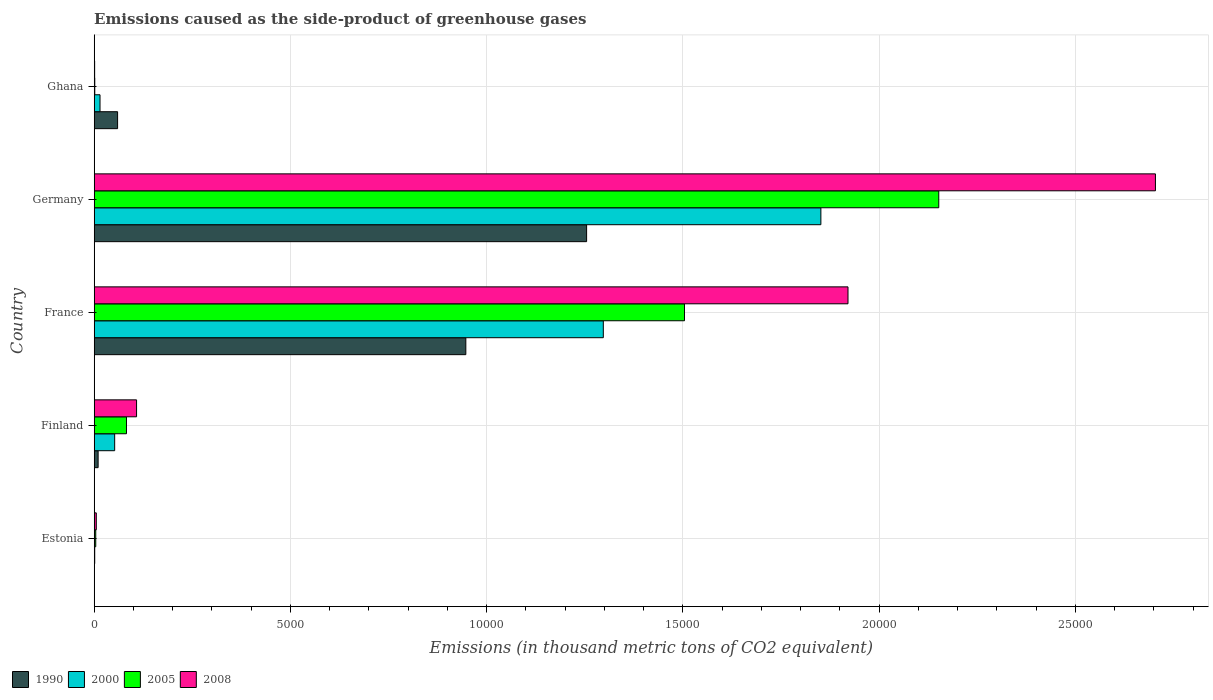How many different coloured bars are there?
Keep it short and to the point. 4. How many bars are there on the 2nd tick from the top?
Your response must be concise. 4. What is the label of the 4th group of bars from the top?
Your answer should be compact. Finland. In how many cases, is the number of bars for a given country not equal to the number of legend labels?
Your answer should be very brief. 0. What is the emissions caused as the side-product of greenhouse gases in 1990 in Ghana?
Ensure brevity in your answer.  596.2. Across all countries, what is the maximum emissions caused as the side-product of greenhouse gases in 2008?
Your answer should be compact. 2.70e+04. In which country was the emissions caused as the side-product of greenhouse gases in 1990 minimum?
Provide a succinct answer. Estonia. What is the total emissions caused as the side-product of greenhouse gases in 2005 in the graph?
Provide a short and direct response. 3.74e+04. What is the difference between the emissions caused as the side-product of greenhouse gases in 2000 in Finland and that in France?
Offer a terse response. -1.24e+04. What is the difference between the emissions caused as the side-product of greenhouse gases in 2005 in Ghana and the emissions caused as the side-product of greenhouse gases in 2000 in Finland?
Give a very brief answer. -507.1. What is the average emissions caused as the side-product of greenhouse gases in 2005 per country?
Keep it short and to the point. 7486.66. What is the difference between the emissions caused as the side-product of greenhouse gases in 2000 and emissions caused as the side-product of greenhouse gases in 2005 in Finland?
Give a very brief answer. -300.7. In how many countries, is the emissions caused as the side-product of greenhouse gases in 2008 greater than 12000 thousand metric tons?
Provide a succinct answer. 2. What is the ratio of the emissions caused as the side-product of greenhouse gases in 2000 in France to that in Ghana?
Your response must be concise. 87.64. What is the difference between the highest and the second highest emissions caused as the side-product of greenhouse gases in 2005?
Provide a short and direct response. 6478.3. What is the difference between the highest and the lowest emissions caused as the side-product of greenhouse gases in 2000?
Your response must be concise. 1.85e+04. In how many countries, is the emissions caused as the side-product of greenhouse gases in 1990 greater than the average emissions caused as the side-product of greenhouse gases in 1990 taken over all countries?
Provide a succinct answer. 2. What is the difference between two consecutive major ticks on the X-axis?
Your answer should be very brief. 5000. Does the graph contain grids?
Your answer should be compact. Yes. How many legend labels are there?
Provide a short and direct response. 4. How are the legend labels stacked?
Offer a terse response. Horizontal. What is the title of the graph?
Ensure brevity in your answer.  Emissions caused as the side-product of greenhouse gases. Does "2006" appear as one of the legend labels in the graph?
Keep it short and to the point. No. What is the label or title of the X-axis?
Your answer should be very brief. Emissions (in thousand metric tons of CO2 equivalent). What is the label or title of the Y-axis?
Make the answer very short. Country. What is the Emissions (in thousand metric tons of CO2 equivalent) in 1990 in Estonia?
Provide a short and direct response. 2.1. What is the Emissions (in thousand metric tons of CO2 equivalent) in 2000 in Estonia?
Your response must be concise. 13.3. What is the Emissions (in thousand metric tons of CO2 equivalent) of 2005 in Estonia?
Keep it short and to the point. 39.4. What is the Emissions (in thousand metric tons of CO2 equivalent) in 2008 in Estonia?
Offer a terse response. 53.3. What is the Emissions (in thousand metric tons of CO2 equivalent) in 1990 in Finland?
Provide a short and direct response. 100.2. What is the Emissions (in thousand metric tons of CO2 equivalent) of 2000 in Finland?
Your response must be concise. 521.8. What is the Emissions (in thousand metric tons of CO2 equivalent) of 2005 in Finland?
Keep it short and to the point. 822.5. What is the Emissions (in thousand metric tons of CO2 equivalent) of 2008 in Finland?
Keep it short and to the point. 1079.5. What is the Emissions (in thousand metric tons of CO2 equivalent) in 1990 in France?
Make the answer very short. 9468.2. What is the Emissions (in thousand metric tons of CO2 equivalent) of 2000 in France?
Keep it short and to the point. 1.30e+04. What is the Emissions (in thousand metric tons of CO2 equivalent) in 2005 in France?
Ensure brevity in your answer.  1.50e+04. What is the Emissions (in thousand metric tons of CO2 equivalent) of 2008 in France?
Your answer should be compact. 1.92e+04. What is the Emissions (in thousand metric tons of CO2 equivalent) in 1990 in Germany?
Offer a very short reply. 1.25e+04. What is the Emissions (in thousand metric tons of CO2 equivalent) in 2000 in Germany?
Provide a short and direct response. 1.85e+04. What is the Emissions (in thousand metric tons of CO2 equivalent) in 2005 in Germany?
Your response must be concise. 2.15e+04. What is the Emissions (in thousand metric tons of CO2 equivalent) of 2008 in Germany?
Your answer should be very brief. 2.70e+04. What is the Emissions (in thousand metric tons of CO2 equivalent) in 1990 in Ghana?
Make the answer very short. 596.2. What is the Emissions (in thousand metric tons of CO2 equivalent) of 2000 in Ghana?
Offer a terse response. 148. What is the Emissions (in thousand metric tons of CO2 equivalent) of 2005 in Ghana?
Keep it short and to the point. 14.7. Across all countries, what is the maximum Emissions (in thousand metric tons of CO2 equivalent) in 1990?
Keep it short and to the point. 1.25e+04. Across all countries, what is the maximum Emissions (in thousand metric tons of CO2 equivalent) of 2000?
Provide a short and direct response. 1.85e+04. Across all countries, what is the maximum Emissions (in thousand metric tons of CO2 equivalent) of 2005?
Your response must be concise. 2.15e+04. Across all countries, what is the maximum Emissions (in thousand metric tons of CO2 equivalent) of 2008?
Give a very brief answer. 2.70e+04. Across all countries, what is the minimum Emissions (in thousand metric tons of CO2 equivalent) in 2005?
Ensure brevity in your answer.  14.7. What is the total Emissions (in thousand metric tons of CO2 equivalent) of 1990 in the graph?
Keep it short and to the point. 2.27e+04. What is the total Emissions (in thousand metric tons of CO2 equivalent) in 2000 in the graph?
Give a very brief answer. 3.22e+04. What is the total Emissions (in thousand metric tons of CO2 equivalent) in 2005 in the graph?
Your response must be concise. 3.74e+04. What is the total Emissions (in thousand metric tons of CO2 equivalent) of 2008 in the graph?
Ensure brevity in your answer.  4.74e+04. What is the difference between the Emissions (in thousand metric tons of CO2 equivalent) in 1990 in Estonia and that in Finland?
Keep it short and to the point. -98.1. What is the difference between the Emissions (in thousand metric tons of CO2 equivalent) in 2000 in Estonia and that in Finland?
Make the answer very short. -508.5. What is the difference between the Emissions (in thousand metric tons of CO2 equivalent) of 2005 in Estonia and that in Finland?
Ensure brevity in your answer.  -783.1. What is the difference between the Emissions (in thousand metric tons of CO2 equivalent) in 2008 in Estonia and that in Finland?
Ensure brevity in your answer.  -1026.2. What is the difference between the Emissions (in thousand metric tons of CO2 equivalent) of 1990 in Estonia and that in France?
Your response must be concise. -9466.1. What is the difference between the Emissions (in thousand metric tons of CO2 equivalent) in 2000 in Estonia and that in France?
Your answer should be very brief. -1.30e+04. What is the difference between the Emissions (in thousand metric tons of CO2 equivalent) in 2005 in Estonia and that in France?
Ensure brevity in your answer.  -1.50e+04. What is the difference between the Emissions (in thousand metric tons of CO2 equivalent) of 2008 in Estonia and that in France?
Your response must be concise. -1.92e+04. What is the difference between the Emissions (in thousand metric tons of CO2 equivalent) in 1990 in Estonia and that in Germany?
Your response must be concise. -1.25e+04. What is the difference between the Emissions (in thousand metric tons of CO2 equivalent) in 2000 in Estonia and that in Germany?
Offer a terse response. -1.85e+04. What is the difference between the Emissions (in thousand metric tons of CO2 equivalent) of 2005 in Estonia and that in Germany?
Give a very brief answer. -2.15e+04. What is the difference between the Emissions (in thousand metric tons of CO2 equivalent) of 2008 in Estonia and that in Germany?
Your response must be concise. -2.70e+04. What is the difference between the Emissions (in thousand metric tons of CO2 equivalent) in 1990 in Estonia and that in Ghana?
Ensure brevity in your answer.  -594.1. What is the difference between the Emissions (in thousand metric tons of CO2 equivalent) in 2000 in Estonia and that in Ghana?
Offer a very short reply. -134.7. What is the difference between the Emissions (in thousand metric tons of CO2 equivalent) of 2005 in Estonia and that in Ghana?
Make the answer very short. 24.7. What is the difference between the Emissions (in thousand metric tons of CO2 equivalent) in 2008 in Estonia and that in Ghana?
Offer a terse response. 42.1. What is the difference between the Emissions (in thousand metric tons of CO2 equivalent) in 1990 in Finland and that in France?
Offer a very short reply. -9368. What is the difference between the Emissions (in thousand metric tons of CO2 equivalent) of 2000 in Finland and that in France?
Keep it short and to the point. -1.24e+04. What is the difference between the Emissions (in thousand metric tons of CO2 equivalent) in 2005 in Finland and that in France?
Provide a short and direct response. -1.42e+04. What is the difference between the Emissions (in thousand metric tons of CO2 equivalent) in 2008 in Finland and that in France?
Your answer should be compact. -1.81e+04. What is the difference between the Emissions (in thousand metric tons of CO2 equivalent) of 1990 in Finland and that in Germany?
Keep it short and to the point. -1.24e+04. What is the difference between the Emissions (in thousand metric tons of CO2 equivalent) in 2000 in Finland and that in Germany?
Keep it short and to the point. -1.80e+04. What is the difference between the Emissions (in thousand metric tons of CO2 equivalent) of 2005 in Finland and that in Germany?
Ensure brevity in your answer.  -2.07e+04. What is the difference between the Emissions (in thousand metric tons of CO2 equivalent) of 2008 in Finland and that in Germany?
Provide a short and direct response. -2.60e+04. What is the difference between the Emissions (in thousand metric tons of CO2 equivalent) in 1990 in Finland and that in Ghana?
Your answer should be compact. -496. What is the difference between the Emissions (in thousand metric tons of CO2 equivalent) in 2000 in Finland and that in Ghana?
Your response must be concise. 373.8. What is the difference between the Emissions (in thousand metric tons of CO2 equivalent) in 2005 in Finland and that in Ghana?
Offer a very short reply. 807.8. What is the difference between the Emissions (in thousand metric tons of CO2 equivalent) of 2008 in Finland and that in Ghana?
Your response must be concise. 1068.3. What is the difference between the Emissions (in thousand metric tons of CO2 equivalent) in 1990 in France and that in Germany?
Ensure brevity in your answer.  -3077.5. What is the difference between the Emissions (in thousand metric tons of CO2 equivalent) in 2000 in France and that in Germany?
Offer a very short reply. -5542.7. What is the difference between the Emissions (in thousand metric tons of CO2 equivalent) of 2005 in France and that in Germany?
Offer a terse response. -6478.3. What is the difference between the Emissions (in thousand metric tons of CO2 equivalent) in 2008 in France and that in Germany?
Make the answer very short. -7832.8. What is the difference between the Emissions (in thousand metric tons of CO2 equivalent) of 1990 in France and that in Ghana?
Make the answer very short. 8872. What is the difference between the Emissions (in thousand metric tons of CO2 equivalent) in 2000 in France and that in Ghana?
Offer a very short reply. 1.28e+04. What is the difference between the Emissions (in thousand metric tons of CO2 equivalent) in 2005 in France and that in Ghana?
Give a very brief answer. 1.50e+04. What is the difference between the Emissions (in thousand metric tons of CO2 equivalent) in 2008 in France and that in Ghana?
Your answer should be compact. 1.92e+04. What is the difference between the Emissions (in thousand metric tons of CO2 equivalent) in 1990 in Germany and that in Ghana?
Give a very brief answer. 1.19e+04. What is the difference between the Emissions (in thousand metric tons of CO2 equivalent) of 2000 in Germany and that in Ghana?
Make the answer very short. 1.84e+04. What is the difference between the Emissions (in thousand metric tons of CO2 equivalent) in 2005 in Germany and that in Ghana?
Your answer should be very brief. 2.15e+04. What is the difference between the Emissions (in thousand metric tons of CO2 equivalent) of 2008 in Germany and that in Ghana?
Provide a succinct answer. 2.70e+04. What is the difference between the Emissions (in thousand metric tons of CO2 equivalent) of 1990 in Estonia and the Emissions (in thousand metric tons of CO2 equivalent) of 2000 in Finland?
Ensure brevity in your answer.  -519.7. What is the difference between the Emissions (in thousand metric tons of CO2 equivalent) of 1990 in Estonia and the Emissions (in thousand metric tons of CO2 equivalent) of 2005 in Finland?
Your answer should be compact. -820.4. What is the difference between the Emissions (in thousand metric tons of CO2 equivalent) in 1990 in Estonia and the Emissions (in thousand metric tons of CO2 equivalent) in 2008 in Finland?
Make the answer very short. -1077.4. What is the difference between the Emissions (in thousand metric tons of CO2 equivalent) of 2000 in Estonia and the Emissions (in thousand metric tons of CO2 equivalent) of 2005 in Finland?
Ensure brevity in your answer.  -809.2. What is the difference between the Emissions (in thousand metric tons of CO2 equivalent) of 2000 in Estonia and the Emissions (in thousand metric tons of CO2 equivalent) of 2008 in Finland?
Provide a short and direct response. -1066.2. What is the difference between the Emissions (in thousand metric tons of CO2 equivalent) of 2005 in Estonia and the Emissions (in thousand metric tons of CO2 equivalent) of 2008 in Finland?
Offer a very short reply. -1040.1. What is the difference between the Emissions (in thousand metric tons of CO2 equivalent) of 1990 in Estonia and the Emissions (in thousand metric tons of CO2 equivalent) of 2000 in France?
Your response must be concise. -1.30e+04. What is the difference between the Emissions (in thousand metric tons of CO2 equivalent) in 1990 in Estonia and the Emissions (in thousand metric tons of CO2 equivalent) in 2005 in France?
Offer a very short reply. -1.50e+04. What is the difference between the Emissions (in thousand metric tons of CO2 equivalent) of 1990 in Estonia and the Emissions (in thousand metric tons of CO2 equivalent) of 2008 in France?
Your answer should be very brief. -1.92e+04. What is the difference between the Emissions (in thousand metric tons of CO2 equivalent) in 2000 in Estonia and the Emissions (in thousand metric tons of CO2 equivalent) in 2005 in France?
Offer a very short reply. -1.50e+04. What is the difference between the Emissions (in thousand metric tons of CO2 equivalent) of 2000 in Estonia and the Emissions (in thousand metric tons of CO2 equivalent) of 2008 in France?
Provide a short and direct response. -1.92e+04. What is the difference between the Emissions (in thousand metric tons of CO2 equivalent) of 2005 in Estonia and the Emissions (in thousand metric tons of CO2 equivalent) of 2008 in France?
Your response must be concise. -1.92e+04. What is the difference between the Emissions (in thousand metric tons of CO2 equivalent) in 1990 in Estonia and the Emissions (in thousand metric tons of CO2 equivalent) in 2000 in Germany?
Your answer should be compact. -1.85e+04. What is the difference between the Emissions (in thousand metric tons of CO2 equivalent) of 1990 in Estonia and the Emissions (in thousand metric tons of CO2 equivalent) of 2005 in Germany?
Provide a short and direct response. -2.15e+04. What is the difference between the Emissions (in thousand metric tons of CO2 equivalent) in 1990 in Estonia and the Emissions (in thousand metric tons of CO2 equivalent) in 2008 in Germany?
Give a very brief answer. -2.70e+04. What is the difference between the Emissions (in thousand metric tons of CO2 equivalent) in 2000 in Estonia and the Emissions (in thousand metric tons of CO2 equivalent) in 2005 in Germany?
Keep it short and to the point. -2.15e+04. What is the difference between the Emissions (in thousand metric tons of CO2 equivalent) in 2000 in Estonia and the Emissions (in thousand metric tons of CO2 equivalent) in 2008 in Germany?
Ensure brevity in your answer.  -2.70e+04. What is the difference between the Emissions (in thousand metric tons of CO2 equivalent) of 2005 in Estonia and the Emissions (in thousand metric tons of CO2 equivalent) of 2008 in Germany?
Offer a terse response. -2.70e+04. What is the difference between the Emissions (in thousand metric tons of CO2 equivalent) of 1990 in Estonia and the Emissions (in thousand metric tons of CO2 equivalent) of 2000 in Ghana?
Your response must be concise. -145.9. What is the difference between the Emissions (in thousand metric tons of CO2 equivalent) in 1990 in Estonia and the Emissions (in thousand metric tons of CO2 equivalent) in 2005 in Ghana?
Keep it short and to the point. -12.6. What is the difference between the Emissions (in thousand metric tons of CO2 equivalent) of 1990 in Estonia and the Emissions (in thousand metric tons of CO2 equivalent) of 2008 in Ghana?
Your answer should be compact. -9.1. What is the difference between the Emissions (in thousand metric tons of CO2 equivalent) in 2000 in Estonia and the Emissions (in thousand metric tons of CO2 equivalent) in 2008 in Ghana?
Offer a very short reply. 2.1. What is the difference between the Emissions (in thousand metric tons of CO2 equivalent) in 2005 in Estonia and the Emissions (in thousand metric tons of CO2 equivalent) in 2008 in Ghana?
Ensure brevity in your answer.  28.2. What is the difference between the Emissions (in thousand metric tons of CO2 equivalent) of 1990 in Finland and the Emissions (in thousand metric tons of CO2 equivalent) of 2000 in France?
Ensure brevity in your answer.  -1.29e+04. What is the difference between the Emissions (in thousand metric tons of CO2 equivalent) in 1990 in Finland and the Emissions (in thousand metric tons of CO2 equivalent) in 2005 in France?
Offer a terse response. -1.49e+04. What is the difference between the Emissions (in thousand metric tons of CO2 equivalent) in 1990 in Finland and the Emissions (in thousand metric tons of CO2 equivalent) in 2008 in France?
Offer a very short reply. -1.91e+04. What is the difference between the Emissions (in thousand metric tons of CO2 equivalent) in 2000 in Finland and the Emissions (in thousand metric tons of CO2 equivalent) in 2005 in France?
Your answer should be compact. -1.45e+04. What is the difference between the Emissions (in thousand metric tons of CO2 equivalent) of 2000 in Finland and the Emissions (in thousand metric tons of CO2 equivalent) of 2008 in France?
Ensure brevity in your answer.  -1.87e+04. What is the difference between the Emissions (in thousand metric tons of CO2 equivalent) of 2005 in Finland and the Emissions (in thousand metric tons of CO2 equivalent) of 2008 in France?
Your answer should be very brief. -1.84e+04. What is the difference between the Emissions (in thousand metric tons of CO2 equivalent) of 1990 in Finland and the Emissions (in thousand metric tons of CO2 equivalent) of 2000 in Germany?
Provide a short and direct response. -1.84e+04. What is the difference between the Emissions (in thousand metric tons of CO2 equivalent) of 1990 in Finland and the Emissions (in thousand metric tons of CO2 equivalent) of 2005 in Germany?
Your answer should be compact. -2.14e+04. What is the difference between the Emissions (in thousand metric tons of CO2 equivalent) of 1990 in Finland and the Emissions (in thousand metric tons of CO2 equivalent) of 2008 in Germany?
Offer a terse response. -2.69e+04. What is the difference between the Emissions (in thousand metric tons of CO2 equivalent) in 2000 in Finland and the Emissions (in thousand metric tons of CO2 equivalent) in 2005 in Germany?
Your response must be concise. -2.10e+04. What is the difference between the Emissions (in thousand metric tons of CO2 equivalent) of 2000 in Finland and the Emissions (in thousand metric tons of CO2 equivalent) of 2008 in Germany?
Make the answer very short. -2.65e+04. What is the difference between the Emissions (in thousand metric tons of CO2 equivalent) of 2005 in Finland and the Emissions (in thousand metric tons of CO2 equivalent) of 2008 in Germany?
Provide a short and direct response. -2.62e+04. What is the difference between the Emissions (in thousand metric tons of CO2 equivalent) in 1990 in Finland and the Emissions (in thousand metric tons of CO2 equivalent) in 2000 in Ghana?
Make the answer very short. -47.8. What is the difference between the Emissions (in thousand metric tons of CO2 equivalent) of 1990 in Finland and the Emissions (in thousand metric tons of CO2 equivalent) of 2005 in Ghana?
Your response must be concise. 85.5. What is the difference between the Emissions (in thousand metric tons of CO2 equivalent) in 1990 in Finland and the Emissions (in thousand metric tons of CO2 equivalent) in 2008 in Ghana?
Make the answer very short. 89. What is the difference between the Emissions (in thousand metric tons of CO2 equivalent) of 2000 in Finland and the Emissions (in thousand metric tons of CO2 equivalent) of 2005 in Ghana?
Provide a short and direct response. 507.1. What is the difference between the Emissions (in thousand metric tons of CO2 equivalent) in 2000 in Finland and the Emissions (in thousand metric tons of CO2 equivalent) in 2008 in Ghana?
Give a very brief answer. 510.6. What is the difference between the Emissions (in thousand metric tons of CO2 equivalent) of 2005 in Finland and the Emissions (in thousand metric tons of CO2 equivalent) of 2008 in Ghana?
Offer a terse response. 811.3. What is the difference between the Emissions (in thousand metric tons of CO2 equivalent) of 1990 in France and the Emissions (in thousand metric tons of CO2 equivalent) of 2000 in Germany?
Your answer should be very brief. -9045.7. What is the difference between the Emissions (in thousand metric tons of CO2 equivalent) in 1990 in France and the Emissions (in thousand metric tons of CO2 equivalent) in 2005 in Germany?
Ensure brevity in your answer.  -1.20e+04. What is the difference between the Emissions (in thousand metric tons of CO2 equivalent) in 1990 in France and the Emissions (in thousand metric tons of CO2 equivalent) in 2008 in Germany?
Provide a short and direct response. -1.76e+04. What is the difference between the Emissions (in thousand metric tons of CO2 equivalent) of 2000 in France and the Emissions (in thousand metric tons of CO2 equivalent) of 2005 in Germany?
Keep it short and to the point. -8546.3. What is the difference between the Emissions (in thousand metric tons of CO2 equivalent) of 2000 in France and the Emissions (in thousand metric tons of CO2 equivalent) of 2008 in Germany?
Offer a terse response. -1.41e+04. What is the difference between the Emissions (in thousand metric tons of CO2 equivalent) in 2005 in France and the Emissions (in thousand metric tons of CO2 equivalent) in 2008 in Germany?
Provide a succinct answer. -1.20e+04. What is the difference between the Emissions (in thousand metric tons of CO2 equivalent) in 1990 in France and the Emissions (in thousand metric tons of CO2 equivalent) in 2000 in Ghana?
Keep it short and to the point. 9320.2. What is the difference between the Emissions (in thousand metric tons of CO2 equivalent) of 1990 in France and the Emissions (in thousand metric tons of CO2 equivalent) of 2005 in Ghana?
Offer a terse response. 9453.5. What is the difference between the Emissions (in thousand metric tons of CO2 equivalent) of 1990 in France and the Emissions (in thousand metric tons of CO2 equivalent) of 2008 in Ghana?
Your answer should be compact. 9457. What is the difference between the Emissions (in thousand metric tons of CO2 equivalent) in 2000 in France and the Emissions (in thousand metric tons of CO2 equivalent) in 2005 in Ghana?
Your response must be concise. 1.30e+04. What is the difference between the Emissions (in thousand metric tons of CO2 equivalent) in 2000 in France and the Emissions (in thousand metric tons of CO2 equivalent) in 2008 in Ghana?
Offer a terse response. 1.30e+04. What is the difference between the Emissions (in thousand metric tons of CO2 equivalent) of 2005 in France and the Emissions (in thousand metric tons of CO2 equivalent) of 2008 in Ghana?
Make the answer very short. 1.50e+04. What is the difference between the Emissions (in thousand metric tons of CO2 equivalent) of 1990 in Germany and the Emissions (in thousand metric tons of CO2 equivalent) of 2000 in Ghana?
Your answer should be very brief. 1.24e+04. What is the difference between the Emissions (in thousand metric tons of CO2 equivalent) in 1990 in Germany and the Emissions (in thousand metric tons of CO2 equivalent) in 2005 in Ghana?
Give a very brief answer. 1.25e+04. What is the difference between the Emissions (in thousand metric tons of CO2 equivalent) of 1990 in Germany and the Emissions (in thousand metric tons of CO2 equivalent) of 2008 in Ghana?
Keep it short and to the point. 1.25e+04. What is the difference between the Emissions (in thousand metric tons of CO2 equivalent) of 2000 in Germany and the Emissions (in thousand metric tons of CO2 equivalent) of 2005 in Ghana?
Keep it short and to the point. 1.85e+04. What is the difference between the Emissions (in thousand metric tons of CO2 equivalent) of 2000 in Germany and the Emissions (in thousand metric tons of CO2 equivalent) of 2008 in Ghana?
Your response must be concise. 1.85e+04. What is the difference between the Emissions (in thousand metric tons of CO2 equivalent) of 2005 in Germany and the Emissions (in thousand metric tons of CO2 equivalent) of 2008 in Ghana?
Ensure brevity in your answer.  2.15e+04. What is the average Emissions (in thousand metric tons of CO2 equivalent) of 1990 per country?
Offer a terse response. 4542.48. What is the average Emissions (in thousand metric tons of CO2 equivalent) of 2000 per country?
Provide a succinct answer. 6433.64. What is the average Emissions (in thousand metric tons of CO2 equivalent) in 2005 per country?
Offer a terse response. 7486.66. What is the average Emissions (in thousand metric tons of CO2 equivalent) in 2008 per country?
Ensure brevity in your answer.  9477.36. What is the difference between the Emissions (in thousand metric tons of CO2 equivalent) in 1990 and Emissions (in thousand metric tons of CO2 equivalent) in 2000 in Estonia?
Your answer should be very brief. -11.2. What is the difference between the Emissions (in thousand metric tons of CO2 equivalent) of 1990 and Emissions (in thousand metric tons of CO2 equivalent) of 2005 in Estonia?
Offer a terse response. -37.3. What is the difference between the Emissions (in thousand metric tons of CO2 equivalent) of 1990 and Emissions (in thousand metric tons of CO2 equivalent) of 2008 in Estonia?
Ensure brevity in your answer.  -51.2. What is the difference between the Emissions (in thousand metric tons of CO2 equivalent) in 2000 and Emissions (in thousand metric tons of CO2 equivalent) in 2005 in Estonia?
Offer a very short reply. -26.1. What is the difference between the Emissions (in thousand metric tons of CO2 equivalent) of 1990 and Emissions (in thousand metric tons of CO2 equivalent) of 2000 in Finland?
Offer a terse response. -421.6. What is the difference between the Emissions (in thousand metric tons of CO2 equivalent) of 1990 and Emissions (in thousand metric tons of CO2 equivalent) of 2005 in Finland?
Your answer should be very brief. -722.3. What is the difference between the Emissions (in thousand metric tons of CO2 equivalent) of 1990 and Emissions (in thousand metric tons of CO2 equivalent) of 2008 in Finland?
Give a very brief answer. -979.3. What is the difference between the Emissions (in thousand metric tons of CO2 equivalent) of 2000 and Emissions (in thousand metric tons of CO2 equivalent) of 2005 in Finland?
Ensure brevity in your answer.  -300.7. What is the difference between the Emissions (in thousand metric tons of CO2 equivalent) of 2000 and Emissions (in thousand metric tons of CO2 equivalent) of 2008 in Finland?
Give a very brief answer. -557.7. What is the difference between the Emissions (in thousand metric tons of CO2 equivalent) of 2005 and Emissions (in thousand metric tons of CO2 equivalent) of 2008 in Finland?
Your response must be concise. -257. What is the difference between the Emissions (in thousand metric tons of CO2 equivalent) of 1990 and Emissions (in thousand metric tons of CO2 equivalent) of 2000 in France?
Make the answer very short. -3503. What is the difference between the Emissions (in thousand metric tons of CO2 equivalent) of 1990 and Emissions (in thousand metric tons of CO2 equivalent) of 2005 in France?
Offer a very short reply. -5571. What is the difference between the Emissions (in thousand metric tons of CO2 equivalent) in 1990 and Emissions (in thousand metric tons of CO2 equivalent) in 2008 in France?
Offer a terse response. -9736.8. What is the difference between the Emissions (in thousand metric tons of CO2 equivalent) of 2000 and Emissions (in thousand metric tons of CO2 equivalent) of 2005 in France?
Your response must be concise. -2068. What is the difference between the Emissions (in thousand metric tons of CO2 equivalent) in 2000 and Emissions (in thousand metric tons of CO2 equivalent) in 2008 in France?
Your answer should be very brief. -6233.8. What is the difference between the Emissions (in thousand metric tons of CO2 equivalent) in 2005 and Emissions (in thousand metric tons of CO2 equivalent) in 2008 in France?
Offer a terse response. -4165.8. What is the difference between the Emissions (in thousand metric tons of CO2 equivalent) in 1990 and Emissions (in thousand metric tons of CO2 equivalent) in 2000 in Germany?
Offer a very short reply. -5968.2. What is the difference between the Emissions (in thousand metric tons of CO2 equivalent) of 1990 and Emissions (in thousand metric tons of CO2 equivalent) of 2005 in Germany?
Provide a succinct answer. -8971.8. What is the difference between the Emissions (in thousand metric tons of CO2 equivalent) in 1990 and Emissions (in thousand metric tons of CO2 equivalent) in 2008 in Germany?
Keep it short and to the point. -1.45e+04. What is the difference between the Emissions (in thousand metric tons of CO2 equivalent) of 2000 and Emissions (in thousand metric tons of CO2 equivalent) of 2005 in Germany?
Give a very brief answer. -3003.6. What is the difference between the Emissions (in thousand metric tons of CO2 equivalent) in 2000 and Emissions (in thousand metric tons of CO2 equivalent) in 2008 in Germany?
Offer a terse response. -8523.9. What is the difference between the Emissions (in thousand metric tons of CO2 equivalent) of 2005 and Emissions (in thousand metric tons of CO2 equivalent) of 2008 in Germany?
Provide a short and direct response. -5520.3. What is the difference between the Emissions (in thousand metric tons of CO2 equivalent) in 1990 and Emissions (in thousand metric tons of CO2 equivalent) in 2000 in Ghana?
Offer a terse response. 448.2. What is the difference between the Emissions (in thousand metric tons of CO2 equivalent) in 1990 and Emissions (in thousand metric tons of CO2 equivalent) in 2005 in Ghana?
Give a very brief answer. 581.5. What is the difference between the Emissions (in thousand metric tons of CO2 equivalent) in 1990 and Emissions (in thousand metric tons of CO2 equivalent) in 2008 in Ghana?
Give a very brief answer. 585. What is the difference between the Emissions (in thousand metric tons of CO2 equivalent) of 2000 and Emissions (in thousand metric tons of CO2 equivalent) of 2005 in Ghana?
Keep it short and to the point. 133.3. What is the difference between the Emissions (in thousand metric tons of CO2 equivalent) in 2000 and Emissions (in thousand metric tons of CO2 equivalent) in 2008 in Ghana?
Ensure brevity in your answer.  136.8. What is the ratio of the Emissions (in thousand metric tons of CO2 equivalent) of 1990 in Estonia to that in Finland?
Provide a succinct answer. 0.02. What is the ratio of the Emissions (in thousand metric tons of CO2 equivalent) in 2000 in Estonia to that in Finland?
Your answer should be very brief. 0.03. What is the ratio of the Emissions (in thousand metric tons of CO2 equivalent) of 2005 in Estonia to that in Finland?
Make the answer very short. 0.05. What is the ratio of the Emissions (in thousand metric tons of CO2 equivalent) in 2008 in Estonia to that in Finland?
Ensure brevity in your answer.  0.05. What is the ratio of the Emissions (in thousand metric tons of CO2 equivalent) of 1990 in Estonia to that in France?
Your response must be concise. 0. What is the ratio of the Emissions (in thousand metric tons of CO2 equivalent) of 2005 in Estonia to that in France?
Your answer should be compact. 0. What is the ratio of the Emissions (in thousand metric tons of CO2 equivalent) of 2008 in Estonia to that in France?
Offer a very short reply. 0. What is the ratio of the Emissions (in thousand metric tons of CO2 equivalent) of 1990 in Estonia to that in Germany?
Keep it short and to the point. 0. What is the ratio of the Emissions (in thousand metric tons of CO2 equivalent) in 2000 in Estonia to that in Germany?
Provide a short and direct response. 0. What is the ratio of the Emissions (in thousand metric tons of CO2 equivalent) in 2005 in Estonia to that in Germany?
Give a very brief answer. 0. What is the ratio of the Emissions (in thousand metric tons of CO2 equivalent) of 2008 in Estonia to that in Germany?
Provide a succinct answer. 0. What is the ratio of the Emissions (in thousand metric tons of CO2 equivalent) in 1990 in Estonia to that in Ghana?
Keep it short and to the point. 0. What is the ratio of the Emissions (in thousand metric tons of CO2 equivalent) of 2000 in Estonia to that in Ghana?
Provide a succinct answer. 0.09. What is the ratio of the Emissions (in thousand metric tons of CO2 equivalent) of 2005 in Estonia to that in Ghana?
Provide a succinct answer. 2.68. What is the ratio of the Emissions (in thousand metric tons of CO2 equivalent) of 2008 in Estonia to that in Ghana?
Your response must be concise. 4.76. What is the ratio of the Emissions (in thousand metric tons of CO2 equivalent) in 1990 in Finland to that in France?
Offer a very short reply. 0.01. What is the ratio of the Emissions (in thousand metric tons of CO2 equivalent) in 2000 in Finland to that in France?
Keep it short and to the point. 0.04. What is the ratio of the Emissions (in thousand metric tons of CO2 equivalent) in 2005 in Finland to that in France?
Keep it short and to the point. 0.05. What is the ratio of the Emissions (in thousand metric tons of CO2 equivalent) in 2008 in Finland to that in France?
Your answer should be compact. 0.06. What is the ratio of the Emissions (in thousand metric tons of CO2 equivalent) of 1990 in Finland to that in Germany?
Ensure brevity in your answer.  0.01. What is the ratio of the Emissions (in thousand metric tons of CO2 equivalent) in 2000 in Finland to that in Germany?
Ensure brevity in your answer.  0.03. What is the ratio of the Emissions (in thousand metric tons of CO2 equivalent) of 2005 in Finland to that in Germany?
Your answer should be very brief. 0.04. What is the ratio of the Emissions (in thousand metric tons of CO2 equivalent) of 2008 in Finland to that in Germany?
Keep it short and to the point. 0.04. What is the ratio of the Emissions (in thousand metric tons of CO2 equivalent) of 1990 in Finland to that in Ghana?
Provide a succinct answer. 0.17. What is the ratio of the Emissions (in thousand metric tons of CO2 equivalent) of 2000 in Finland to that in Ghana?
Make the answer very short. 3.53. What is the ratio of the Emissions (in thousand metric tons of CO2 equivalent) of 2005 in Finland to that in Ghana?
Your response must be concise. 55.95. What is the ratio of the Emissions (in thousand metric tons of CO2 equivalent) in 2008 in Finland to that in Ghana?
Provide a succinct answer. 96.38. What is the ratio of the Emissions (in thousand metric tons of CO2 equivalent) of 1990 in France to that in Germany?
Give a very brief answer. 0.75. What is the ratio of the Emissions (in thousand metric tons of CO2 equivalent) in 2000 in France to that in Germany?
Keep it short and to the point. 0.7. What is the ratio of the Emissions (in thousand metric tons of CO2 equivalent) of 2005 in France to that in Germany?
Make the answer very short. 0.7. What is the ratio of the Emissions (in thousand metric tons of CO2 equivalent) of 2008 in France to that in Germany?
Your response must be concise. 0.71. What is the ratio of the Emissions (in thousand metric tons of CO2 equivalent) in 1990 in France to that in Ghana?
Provide a short and direct response. 15.88. What is the ratio of the Emissions (in thousand metric tons of CO2 equivalent) in 2000 in France to that in Ghana?
Your answer should be very brief. 87.64. What is the ratio of the Emissions (in thousand metric tons of CO2 equivalent) in 2005 in France to that in Ghana?
Offer a terse response. 1023.07. What is the ratio of the Emissions (in thousand metric tons of CO2 equivalent) in 2008 in France to that in Ghana?
Your answer should be very brief. 1714.73. What is the ratio of the Emissions (in thousand metric tons of CO2 equivalent) of 1990 in Germany to that in Ghana?
Provide a succinct answer. 21.04. What is the ratio of the Emissions (in thousand metric tons of CO2 equivalent) in 2000 in Germany to that in Ghana?
Provide a succinct answer. 125.09. What is the ratio of the Emissions (in thousand metric tons of CO2 equivalent) of 2005 in Germany to that in Ghana?
Offer a very short reply. 1463.78. What is the ratio of the Emissions (in thousand metric tons of CO2 equivalent) in 2008 in Germany to that in Ghana?
Offer a very short reply. 2414.09. What is the difference between the highest and the second highest Emissions (in thousand metric tons of CO2 equivalent) in 1990?
Your answer should be compact. 3077.5. What is the difference between the highest and the second highest Emissions (in thousand metric tons of CO2 equivalent) in 2000?
Your response must be concise. 5542.7. What is the difference between the highest and the second highest Emissions (in thousand metric tons of CO2 equivalent) of 2005?
Offer a very short reply. 6478.3. What is the difference between the highest and the second highest Emissions (in thousand metric tons of CO2 equivalent) in 2008?
Your response must be concise. 7832.8. What is the difference between the highest and the lowest Emissions (in thousand metric tons of CO2 equivalent) of 1990?
Give a very brief answer. 1.25e+04. What is the difference between the highest and the lowest Emissions (in thousand metric tons of CO2 equivalent) in 2000?
Provide a short and direct response. 1.85e+04. What is the difference between the highest and the lowest Emissions (in thousand metric tons of CO2 equivalent) of 2005?
Your response must be concise. 2.15e+04. What is the difference between the highest and the lowest Emissions (in thousand metric tons of CO2 equivalent) in 2008?
Offer a very short reply. 2.70e+04. 